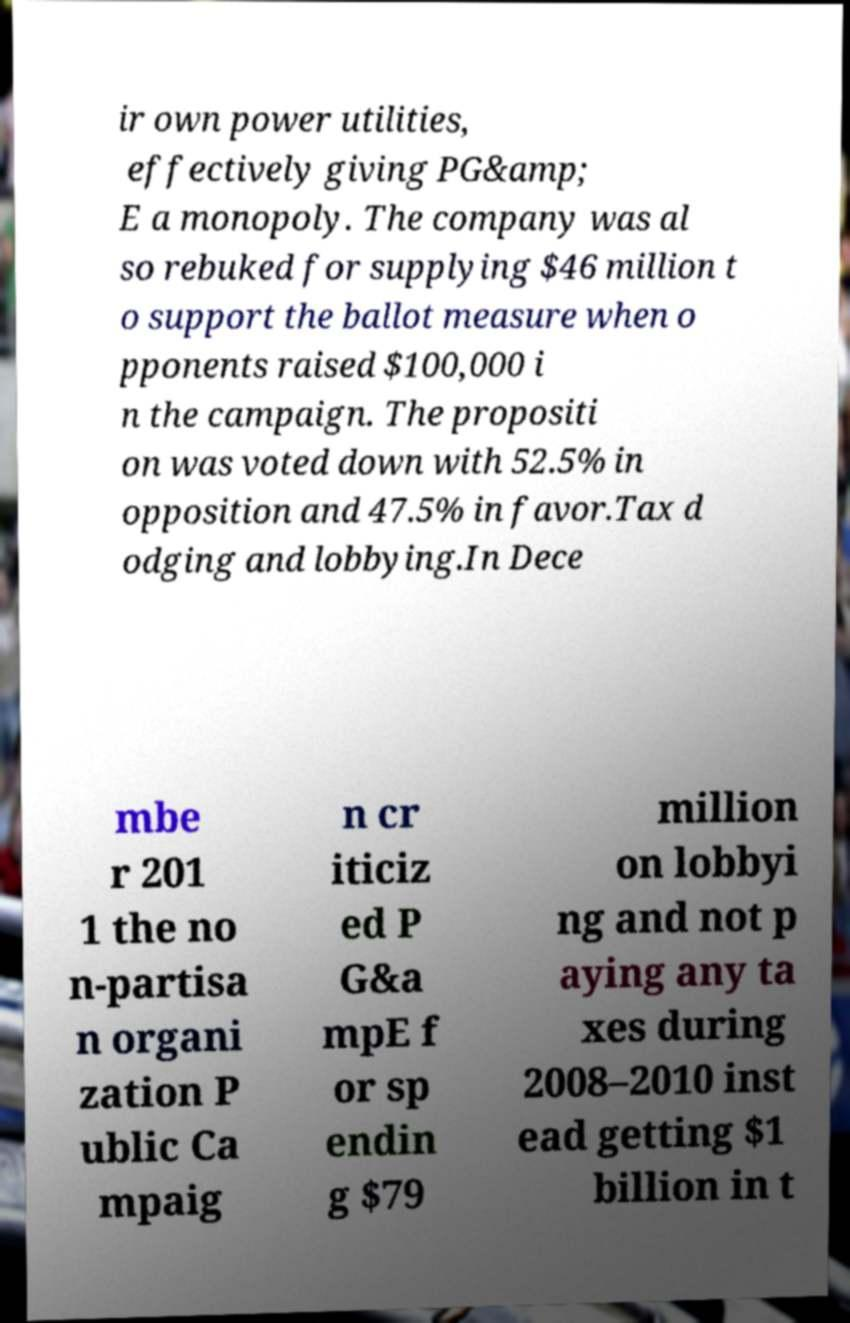Could you assist in decoding the text presented in this image and type it out clearly? ir own power utilities, effectively giving PG&amp; E a monopoly. The company was al so rebuked for supplying $46 million t o support the ballot measure when o pponents raised $100,000 i n the campaign. The propositi on was voted down with 52.5% in opposition and 47.5% in favor.Tax d odging and lobbying.In Dece mbe r 201 1 the no n-partisa n organi zation P ublic Ca mpaig n cr iticiz ed P G&a mpE f or sp endin g $79 million on lobbyi ng and not p aying any ta xes during 2008–2010 inst ead getting $1 billion in t 